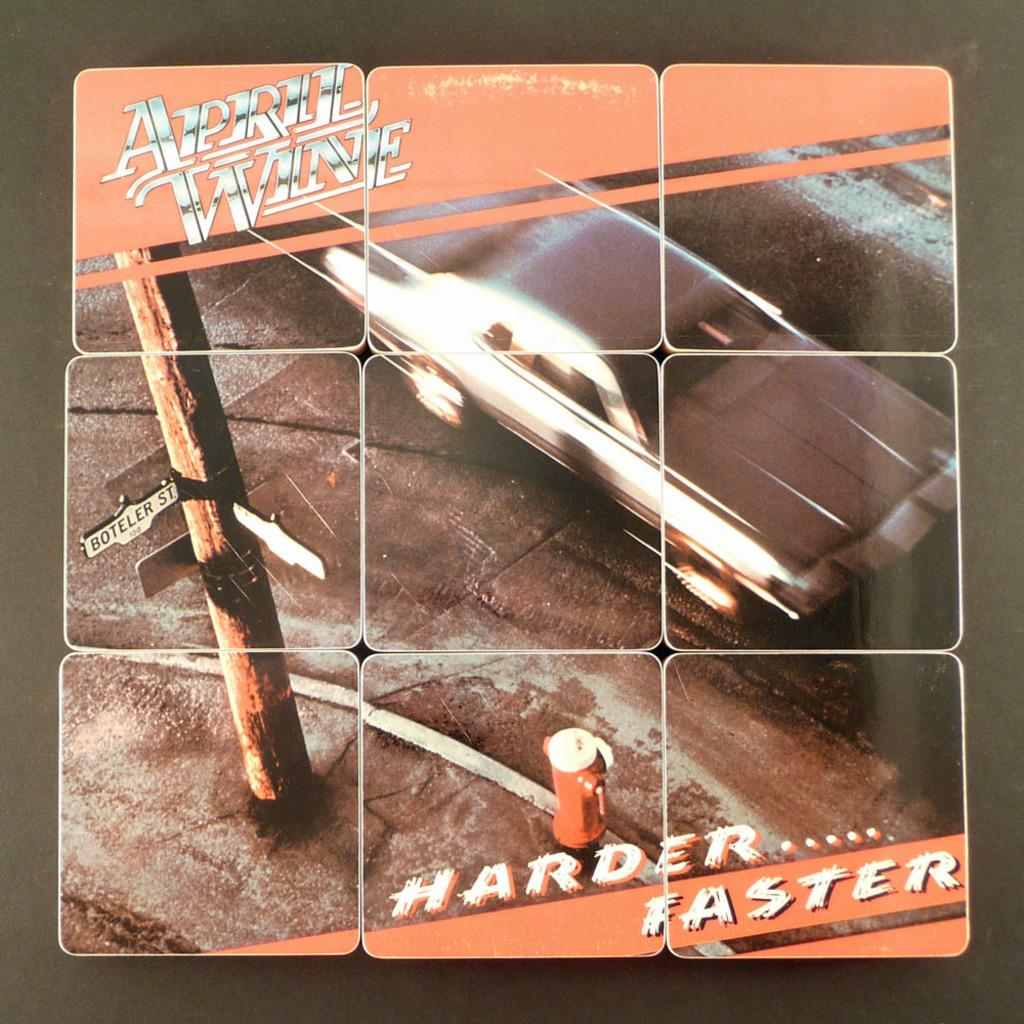<image>
Summarize the visual content of the image. April Wine's album cover entitled Harder....Faster with a car on the front. 